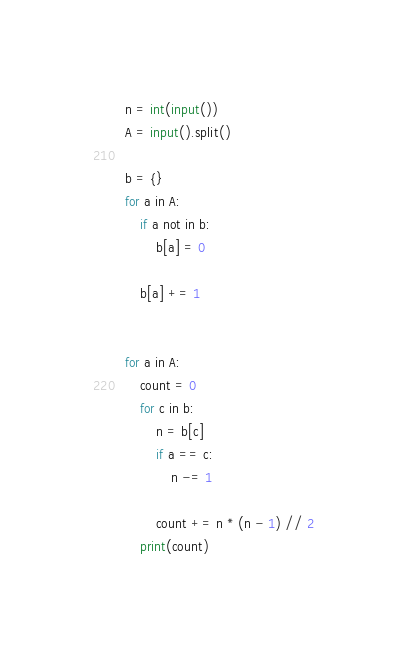Convert code to text. <code><loc_0><loc_0><loc_500><loc_500><_Python_>n = int(input())
A = input().split()

b = {}
for a in A:
    if a not in b:
        b[a] = 0
        
    b[a] += 1


for a in A:
    count = 0
    for c in b:
        n = b[c]
        if a == c:
            n -= 1
        
        count += n * (n - 1) // 2
    print(count)</code> 